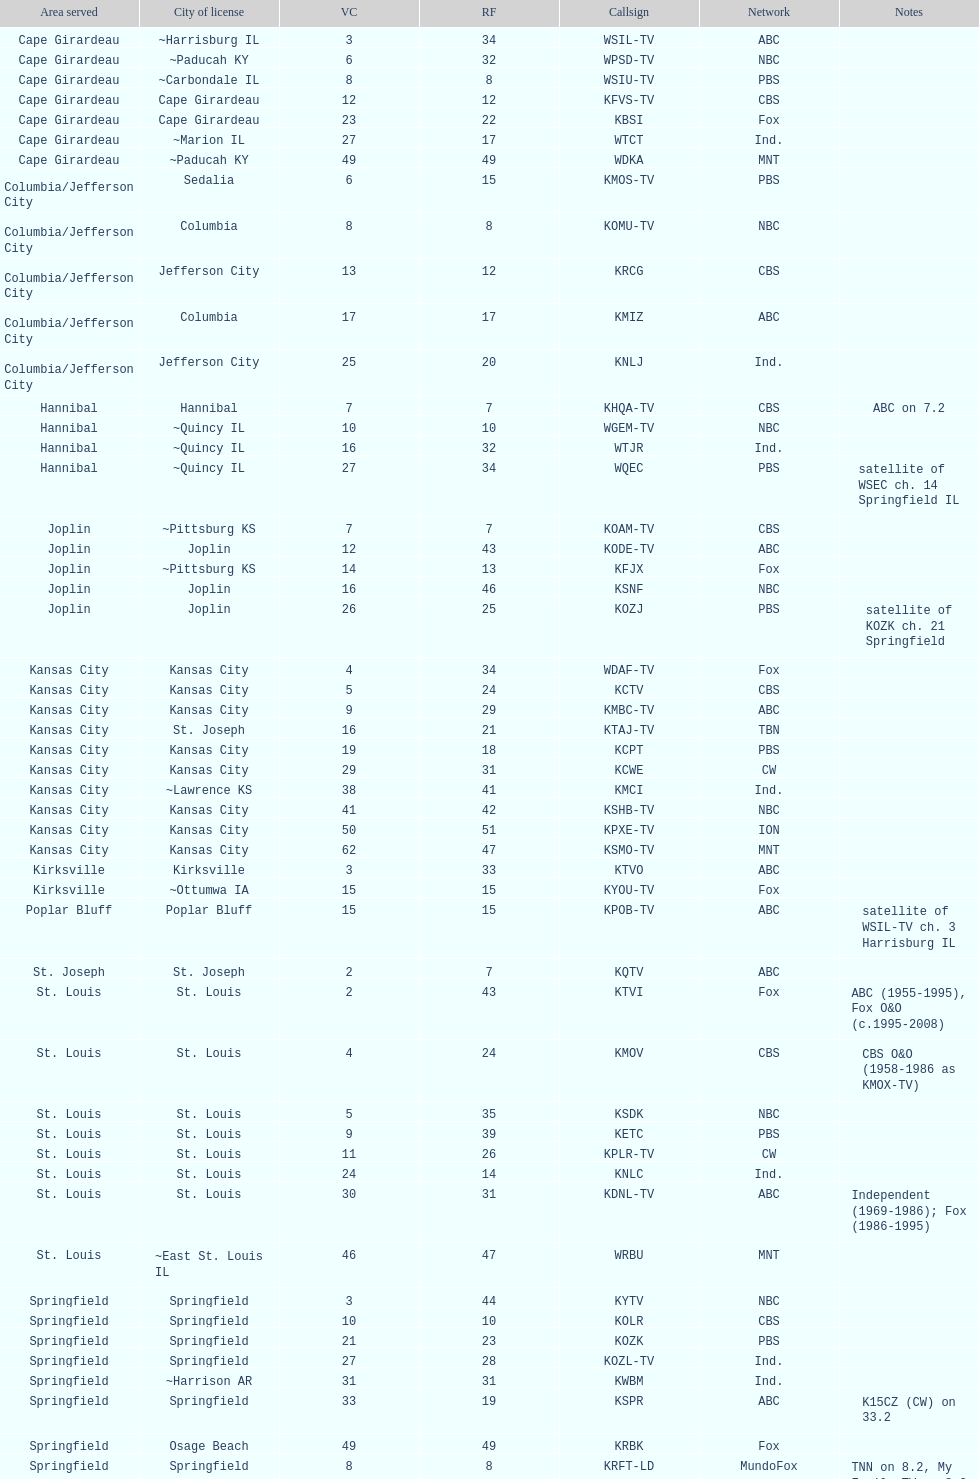How many areas have at least 5 stations? 6. 